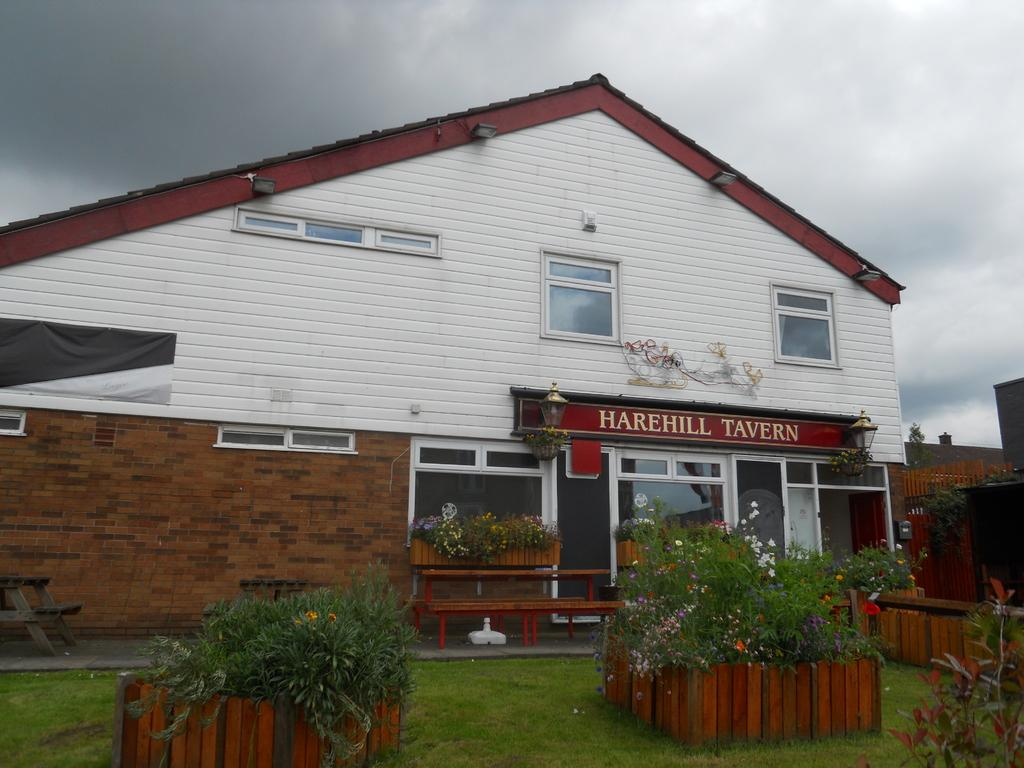What is the main subject of the image? The main subject of the image is a building. Can you describe the entrance to the building? There is a glass entrance door to the building. What type of surface is in front of the building? Grass is present on the surface in front of the building. Are there any plants visible in the image? Yes, there are plants with flowers in front of the building. Can you tell me how deep the ocean is in the image? There is no ocean present in the image; it features a building with a grassy surface and plants with flowers. What type of education is being offered at the building in the image? The image does not provide any information about the type of education being offered at the building. 